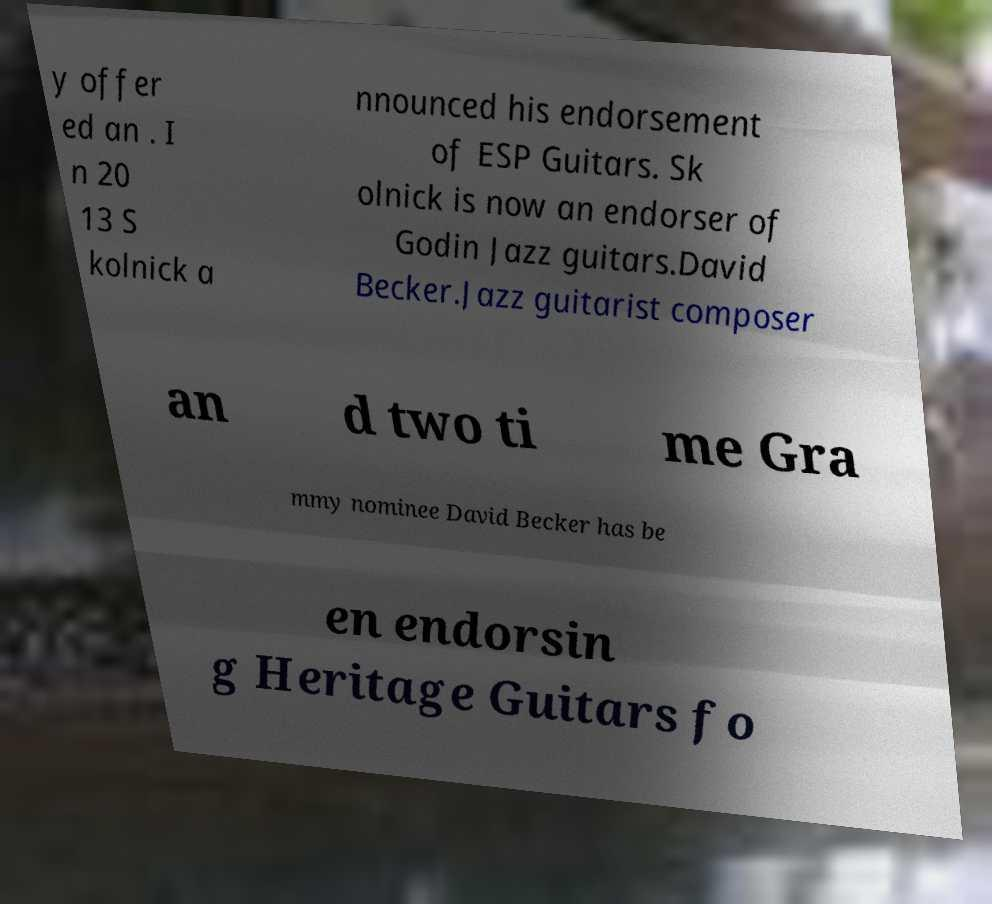Could you extract and type out the text from this image? y offer ed an . I n 20 13 S kolnick a nnounced his endorsement of ESP Guitars. Sk olnick is now an endorser of Godin Jazz guitars.David Becker.Jazz guitarist composer an d two ti me Gra mmy nominee David Becker has be en endorsin g Heritage Guitars fo 